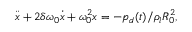<formula> <loc_0><loc_0><loc_500><loc_500>\ddot { x } + 2 \delta \omega _ { 0 } \dot { x } + \omega _ { 0 } ^ { 2 } x = - p _ { d } ( t ) / \rho _ { l } R _ { 0 } ^ { 2 } ,</formula> 